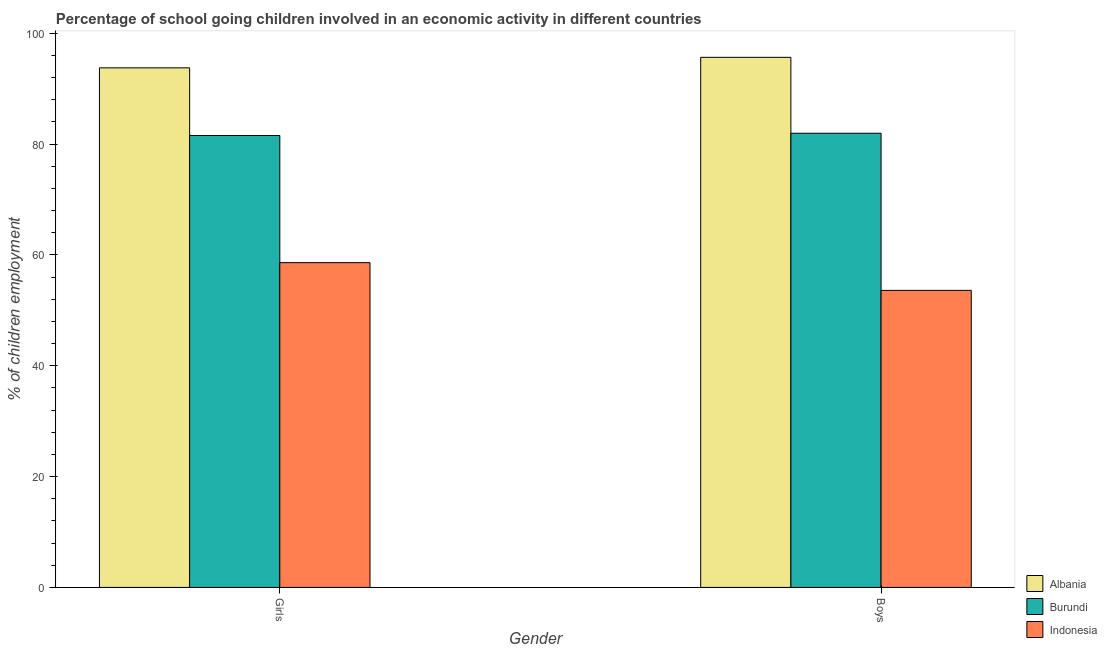How many different coloured bars are there?
Your answer should be very brief. 3. Are the number of bars per tick equal to the number of legend labels?
Ensure brevity in your answer.  Yes. How many bars are there on the 1st tick from the right?
Keep it short and to the point. 3. What is the label of the 1st group of bars from the left?
Provide a short and direct response. Girls. What is the percentage of school going girls in Indonesia?
Keep it short and to the point. 58.6. Across all countries, what is the maximum percentage of school going girls?
Make the answer very short. 93.76. Across all countries, what is the minimum percentage of school going girls?
Provide a short and direct response. 58.6. In which country was the percentage of school going girls maximum?
Ensure brevity in your answer.  Albania. In which country was the percentage of school going boys minimum?
Make the answer very short. Indonesia. What is the total percentage of school going boys in the graph?
Your response must be concise. 231.21. What is the difference between the percentage of school going girls in Albania and that in Indonesia?
Your answer should be very brief. 35.16. What is the difference between the percentage of school going girls in Albania and the percentage of school going boys in Indonesia?
Give a very brief answer. 40.16. What is the average percentage of school going boys per country?
Offer a very short reply. 77.07. In how many countries, is the percentage of school going girls greater than 84 %?
Your answer should be very brief. 1. What is the ratio of the percentage of school going boys in Indonesia to that in Albania?
Your response must be concise. 0.56. In how many countries, is the percentage of school going girls greater than the average percentage of school going girls taken over all countries?
Your response must be concise. 2. What does the 1st bar from the left in Girls represents?
Provide a succinct answer. Albania. What does the 2nd bar from the right in Girls represents?
Offer a very short reply. Burundi. How many bars are there?
Provide a short and direct response. 6. What is the difference between two consecutive major ticks on the Y-axis?
Ensure brevity in your answer.  20. Are the values on the major ticks of Y-axis written in scientific E-notation?
Your response must be concise. No. Does the graph contain grids?
Your answer should be very brief. No. Where does the legend appear in the graph?
Offer a very short reply. Bottom right. How many legend labels are there?
Your answer should be very brief. 3. How are the legend labels stacked?
Ensure brevity in your answer.  Vertical. What is the title of the graph?
Your answer should be compact. Percentage of school going children involved in an economic activity in different countries. Does "Oman" appear as one of the legend labels in the graph?
Provide a short and direct response. No. What is the label or title of the Y-axis?
Provide a short and direct response. % of children employment. What is the % of children employment in Albania in Girls?
Your answer should be very brief. 93.76. What is the % of children employment of Burundi in Girls?
Your answer should be compact. 81.54. What is the % of children employment of Indonesia in Girls?
Offer a very short reply. 58.6. What is the % of children employment in Albania in Boys?
Ensure brevity in your answer.  95.65. What is the % of children employment of Burundi in Boys?
Your answer should be very brief. 81.96. What is the % of children employment in Indonesia in Boys?
Offer a very short reply. 53.6. Across all Gender, what is the maximum % of children employment in Albania?
Offer a very short reply. 95.65. Across all Gender, what is the maximum % of children employment of Burundi?
Ensure brevity in your answer.  81.96. Across all Gender, what is the maximum % of children employment of Indonesia?
Make the answer very short. 58.6. Across all Gender, what is the minimum % of children employment in Albania?
Your answer should be very brief. 93.76. Across all Gender, what is the minimum % of children employment in Burundi?
Offer a very short reply. 81.54. Across all Gender, what is the minimum % of children employment in Indonesia?
Provide a short and direct response. 53.6. What is the total % of children employment of Albania in the graph?
Offer a very short reply. 189.41. What is the total % of children employment in Burundi in the graph?
Give a very brief answer. 163.5. What is the total % of children employment in Indonesia in the graph?
Your answer should be compact. 112.2. What is the difference between the % of children employment in Albania in Girls and that in Boys?
Keep it short and to the point. -1.89. What is the difference between the % of children employment of Burundi in Girls and that in Boys?
Provide a succinct answer. -0.41. What is the difference between the % of children employment of Albania in Girls and the % of children employment of Burundi in Boys?
Your answer should be compact. 11.8. What is the difference between the % of children employment of Albania in Girls and the % of children employment of Indonesia in Boys?
Offer a very short reply. 40.16. What is the difference between the % of children employment in Burundi in Girls and the % of children employment in Indonesia in Boys?
Your answer should be compact. 27.94. What is the average % of children employment of Albania per Gender?
Give a very brief answer. 94.71. What is the average % of children employment of Burundi per Gender?
Make the answer very short. 81.75. What is the average % of children employment of Indonesia per Gender?
Offer a very short reply. 56.1. What is the difference between the % of children employment in Albania and % of children employment in Burundi in Girls?
Your answer should be very brief. 12.21. What is the difference between the % of children employment in Albania and % of children employment in Indonesia in Girls?
Provide a succinct answer. 35.16. What is the difference between the % of children employment in Burundi and % of children employment in Indonesia in Girls?
Provide a short and direct response. 22.94. What is the difference between the % of children employment in Albania and % of children employment in Burundi in Boys?
Ensure brevity in your answer.  13.7. What is the difference between the % of children employment in Albania and % of children employment in Indonesia in Boys?
Ensure brevity in your answer.  42.05. What is the difference between the % of children employment in Burundi and % of children employment in Indonesia in Boys?
Offer a terse response. 28.36. What is the ratio of the % of children employment in Albania in Girls to that in Boys?
Ensure brevity in your answer.  0.98. What is the ratio of the % of children employment of Indonesia in Girls to that in Boys?
Your response must be concise. 1.09. What is the difference between the highest and the second highest % of children employment of Albania?
Offer a very short reply. 1.89. What is the difference between the highest and the second highest % of children employment in Burundi?
Provide a short and direct response. 0.41. What is the difference between the highest and the second highest % of children employment of Indonesia?
Offer a terse response. 5. What is the difference between the highest and the lowest % of children employment in Albania?
Keep it short and to the point. 1.89. What is the difference between the highest and the lowest % of children employment in Burundi?
Provide a succinct answer. 0.41. 